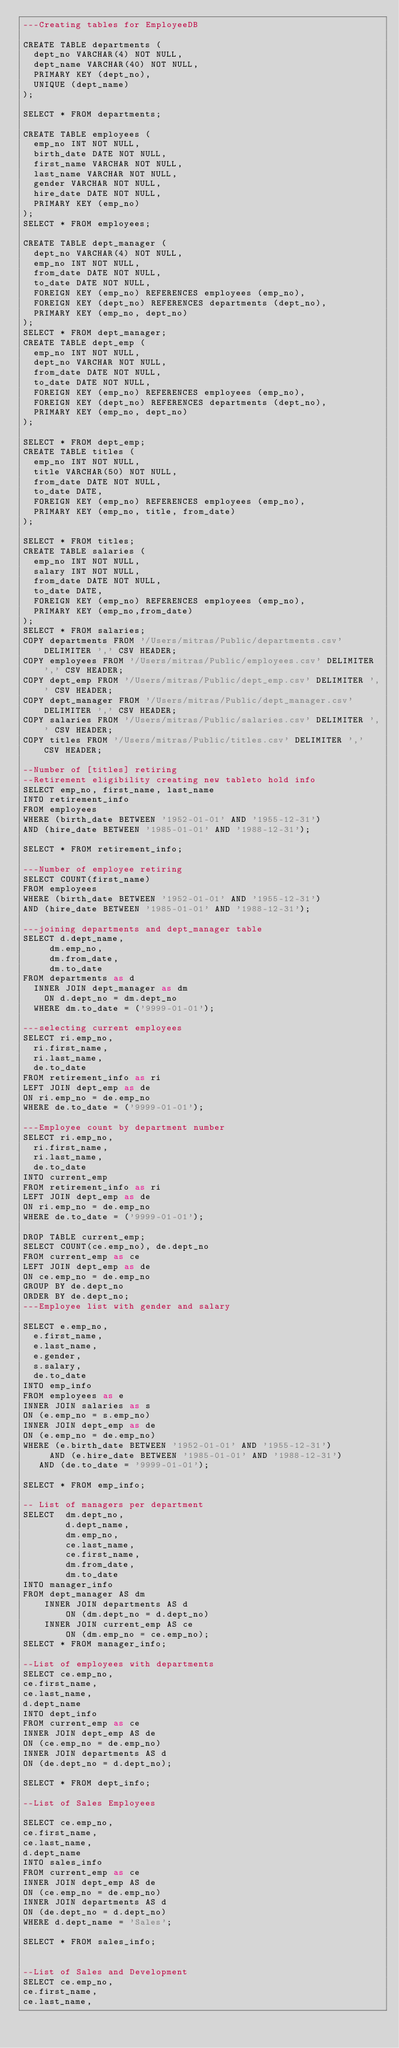<code> <loc_0><loc_0><loc_500><loc_500><_SQL_>---Creating tables for EmployeeDB

CREATE TABLE departments (
	dept_no VARCHAR(4) NOT NULL,
	dept_name VARCHAR(40) NOT NULL,
	PRIMARY KEY (dept_no),
	UNIQUE (dept_name)
);

SELECT * FROM departments;

CREATE TABLE employees (
	emp_no INT NOT NULL,
	birth_date DATE NOT NULL,
	first_name VARCHAR NOT NULL,
	last_name VARCHAR NOT NULL,
	gender VARCHAR NOT NULL,
	hire_date DATE NOT NULL,
	PRIMARY KEY (emp_no)
);
SELECT * FROM employees;

CREATE TABLE dept_manager (
	dept_no VARCHAR(4) NOT NULL,
	emp_no INT NOT NULL,
	from_date DATE NOT NULL,
	to_date DATE NOT NULL,
	FOREIGN KEY (emp_no) REFERENCES employees (emp_no),
	FOREIGN KEY (dept_no) REFERENCES departments (dept_no),
	PRIMARY KEY (emp_no, dept_no)	
);
SELECT * FROM dept_manager;
CREATE TABLE dept_emp (
	emp_no INT NOT NULL,
	dept_no VARCHAR NOT NULL,
	from_date DATE NOT NULL,
	to_date DATE NOT NULL,
	FOREIGN KEY (emp_no) REFERENCES employees (emp_no),
	FOREIGN KEY (dept_no) REFERENCES departments (dept_no),
	PRIMARY KEY (emp_no, dept_no)	
);

SELECT * FROM dept_emp;
CREATE TABLE titles (
	emp_no INT NOT NULL,
	title VARCHAR(50) NOT NULL,
	from_date DATE NOT NULL,
	to_date DATE,
	FOREIGN KEY (emp_no) REFERENCES employees (emp_no),
	PRIMARY KEY (emp_no, title, from_date)	
);

SELECT * FROM titles;
CREATE TABLE salaries (
	emp_no INT NOT NULL,
	salary INT NOT NULL,
	from_date DATE NOT NULL,
	to_date DATE,
	FOREIGN KEY (emp_no) REFERENCES employees (emp_no),
	PRIMARY KEY (emp_no,from_date)	
);
SELECT * FROM salaries;
COPY departments FROM '/Users/mitras/Public/departments.csv' DELIMITER ',' CSV HEADER;
COPY employees FROM '/Users/mitras/Public/employees.csv' DELIMITER ',' CSV HEADER;
COPY dept_emp FROM '/Users/mitras/Public/dept_emp.csv' DELIMITER ',' CSV HEADER;
COPY dept_manager FROM '/Users/mitras/Public/dept_manager.csv' DELIMITER ',' CSV HEADER;
COPY salaries FROM '/Users/mitras/Public/salaries.csv' DELIMITER ',' CSV HEADER;
COPY titles FROM '/Users/mitras/Public/titles.csv' DELIMITER ',' CSV HEADER;

--Number of [titles] retiring
--Retirement eligibility creating new tableto hold info
SELECT emp_no, first_name, last_name
INTO retirement_info
FROM employees
WHERE (birth_date BETWEEN '1952-01-01' AND '1955-12-31')
AND (hire_date BETWEEN '1985-01-01' AND '1988-12-31');

SELECT * FROM retirement_info;

---Number of employee retiring 
SELECT COUNT(first_name)
FROM employees
WHERE (birth_date BETWEEN '1952-01-01' AND '1955-12-31')
AND (hire_date BETWEEN '1985-01-01' AND '1988-12-31');

---joining departments and dept_manager table
SELECT d.dept_name,
     dm.emp_no,
     dm.from_date,
     dm.to_date
FROM departments as d
	INNER JOIN dept_manager as dm
		ON d.dept_no = dm.dept_no
	WHERE dm.to_date = ('9999-01-01');

---selecting current employees
SELECT ri.emp_no,
	ri.first_name,
	ri.last_name,
	de.to_date 
FROM retirement_info as ri
LEFT JOIN dept_emp as de
ON ri.emp_no = de.emp_no
WHERE de.to_date = ('9999-01-01');

---Employee count by department number
SELECT ri.emp_no,
	ri.first_name,
	ri.last_name,
	de.to_date
INTO current_emp	
FROM retirement_info as ri
LEFT JOIN dept_emp as de
ON ri.emp_no = de.emp_no
WHERE de.to_date = ('9999-01-01');

DROP TABLE current_emp;
SELECT COUNT(ce.emp_no), de.dept_no
FROM current_emp as ce
LEFT JOIN dept_emp as de
ON ce.emp_no = de.emp_no
GROUP BY de.dept_no
ORDER BY de.dept_no;
---Employee list with gender and salary

SELECT e.emp_no,
	e.first_name,
	e.last_name,
	e.gender,
	s.salary,
	de.to_date
INTO emp_info
FROM employees as e
INNER JOIN salaries as s
ON (e.emp_no = s.emp_no)
INNER JOIN dept_emp as de
ON (e.emp_no = de.emp_no)
WHERE (e.birth_date BETWEEN '1952-01-01' AND '1955-12-31')
     AND (e.hire_date BETWEEN '1985-01-01' AND '1988-12-31')
	 AND (de.to_date = '9999-01-01');
	 
SELECT * FROM emp_info;

-- List of managers per department
SELECT  dm.dept_no,
        d.dept_name,
        dm.emp_no,
        ce.last_name,
        ce.first_name,
        dm.from_date,
        dm.to_date
INTO manager_info
FROM dept_manager AS dm
    INNER JOIN departments AS d
        ON (dm.dept_no = d.dept_no)
    INNER JOIN current_emp AS ce
        ON (dm.emp_no = ce.emp_no);
SELECT * FROM manager_info;

--List of employees with departments 
SELECT ce.emp_no,
ce.first_name,
ce.last_name,
d.dept_name	
INTO dept_info
FROM current_emp as ce
INNER JOIN dept_emp AS de
ON (ce.emp_no = de.emp_no)
INNER JOIN departments AS d
ON (de.dept_no = d.dept_no);

SELECT * FROM dept_info;

--List of Sales Employees

SELECT ce.emp_no,
ce.first_name,
ce.last_name,
d.dept_name	
INTO sales_info
FROM current_emp as ce
INNER JOIN dept_emp AS de
ON (ce.emp_no = de.emp_no)
INNER JOIN departments AS d
ON (de.dept_no = d.dept_no)
WHERE d.dept_name = 'Sales';

SELECT * FROM sales_info;


--List of Sales and Development
SELECT ce.emp_no,
ce.first_name,
ce.last_name,</code> 